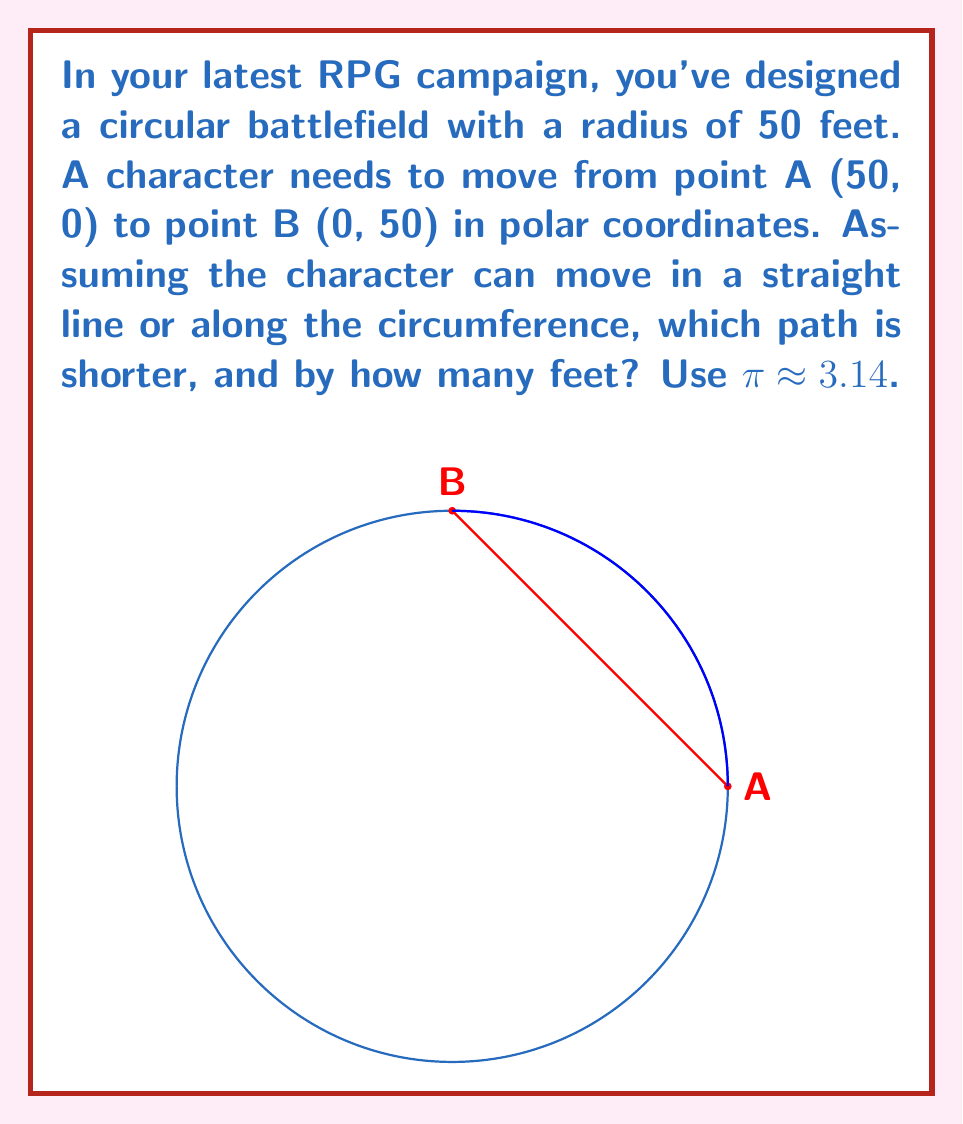What is the answer to this math problem? Let's approach this step-by-step:

1) First, let's calculate the length of the straight path (red line):
   This is the chord of the circle. We can use the distance formula in polar coordinates:
   $$d = \sqrt{r_1^2 + r_2^2 - 2r_1r_2\cos(\theta_2 - \theta_1)}$$
   where $r_1 = r_2 = 50$, $\theta_1 = 0$, and $\theta_2 = \frac{\pi}{2}$
   
   $$d = \sqrt{50^2 + 50^2 - 2(50)(50)\cos(\frac{\pi}{2} - 0)}$$
   $$d = \sqrt{5000 - 5000\cos(\frac{\pi}{2})}$$
   $$d = \sqrt{5000} = 50\sqrt{2} \approx 70.71 \text{ feet}$$

2) Now, let's calculate the length of the path along the circumference (blue arc):
   The arc length is given by $s = r\theta$, where $\theta$ is in radians.
   Here, $r = 50$ and $\theta = \frac{\pi}{2}$
   
   $$s = 50 \cdot \frac{\pi}{2} = 25\pi \approx 78.54 \text{ feet}$$

3) The difference between these paths is:
   $$78.54 - 70.71 = 7.83 \text{ feet}$$

Therefore, the straight line path is shorter by approximately 7.83 feet.
Answer: Straight line; 7.83 feet shorter 